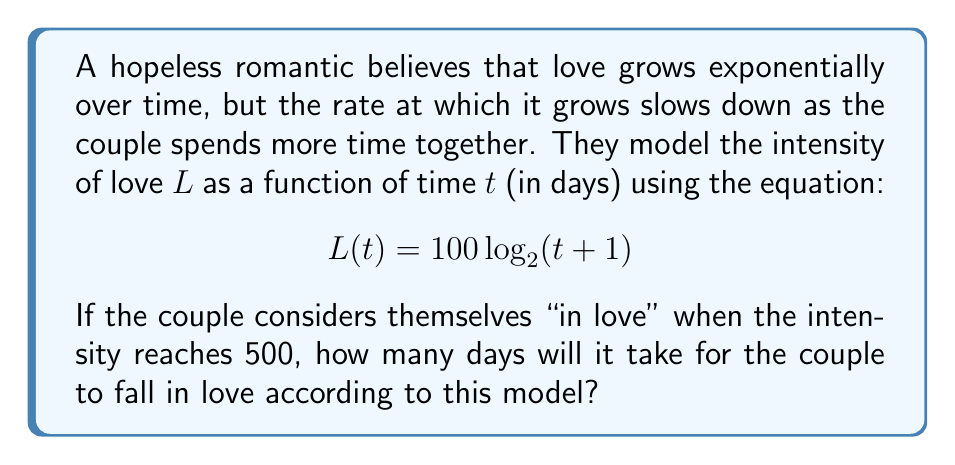Can you solve this math problem? To solve this problem, we need to use the given logarithmic equation and solve for $t$ when $L(t) = 500$. Let's approach this step-by-step:

1) We start with the equation: $L(t) = 100 \log_2(t + 1)$

2) We want to find $t$ when $L(t) = 500$, so we set up the equation:
   $$500 = 100 \log_2(t + 1)$$

3) Divide both sides by 100:
   $$5 = \log_2(t + 1)$$

4) To solve for $t$, we need to apply the inverse function of $\log_2$, which is $2^x$:
   $$2^5 = t + 1$$

5) Simplify the left side:
   $$32 = t + 1$$

6) Subtract 1 from both sides:
   $$31 = t$$

Therefore, according to this model, it will take 31 days for the couple to fall in love.

Note: This model, while mathematically interesting, is a simplification and doesn't reflect the complex nature of human emotions and relationships. As a hopeless romantic would likely agree, love is not something that can be precisely quantified or predicted by equations.
Answer: 31 days 